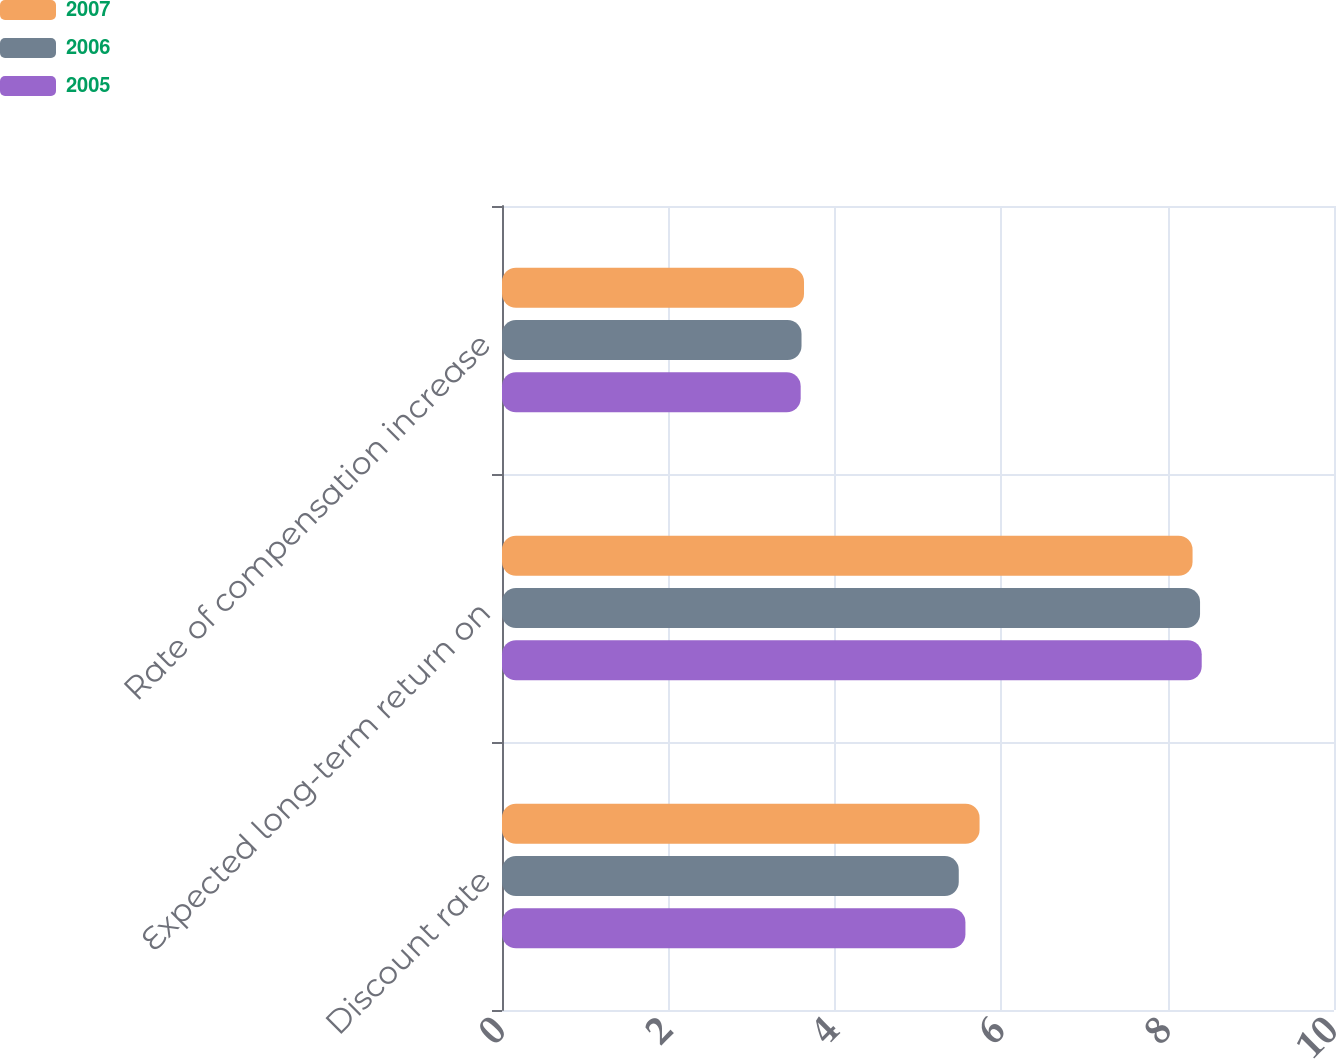Convert chart to OTSL. <chart><loc_0><loc_0><loc_500><loc_500><stacked_bar_chart><ecel><fcel>Discount rate<fcel>Expected long-term return on<fcel>Rate of compensation increase<nl><fcel>2007<fcel>5.74<fcel>8.3<fcel>3.63<nl><fcel>2006<fcel>5.49<fcel>8.39<fcel>3.6<nl><fcel>2005<fcel>5.57<fcel>8.41<fcel>3.59<nl></chart> 